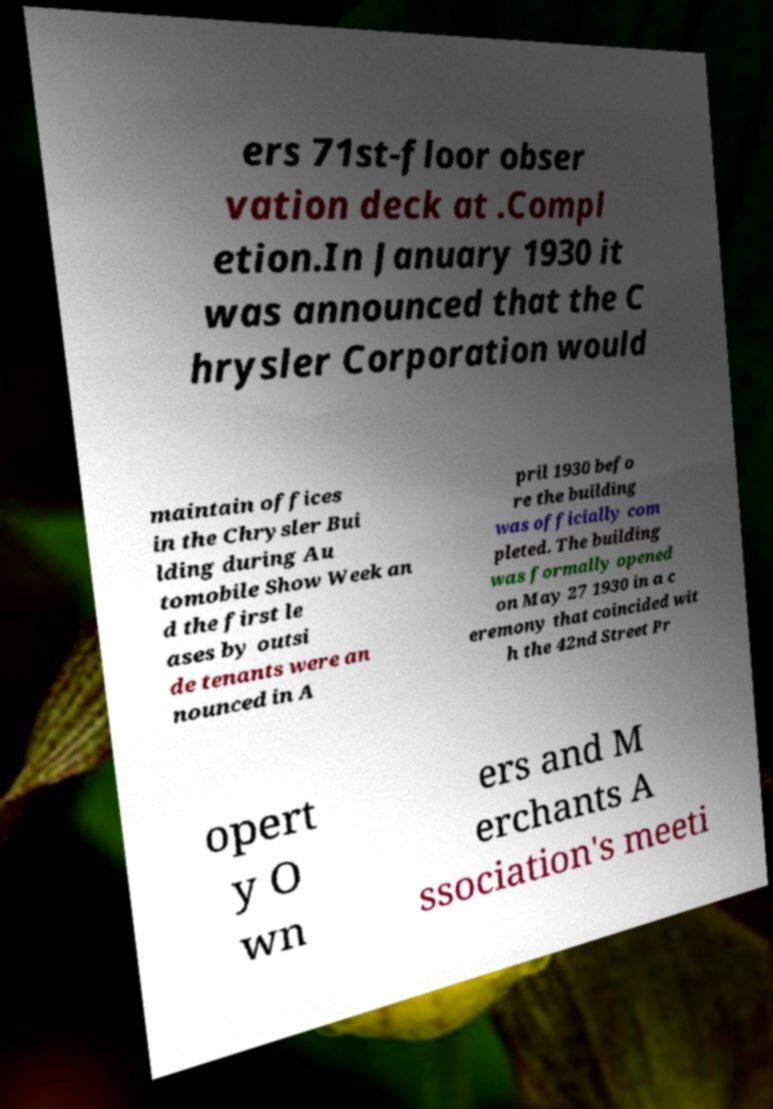Can you accurately transcribe the text from the provided image for me? ers 71st-floor obser vation deck at .Compl etion.In January 1930 it was announced that the C hrysler Corporation would maintain offices in the Chrysler Bui lding during Au tomobile Show Week an d the first le ases by outsi de tenants were an nounced in A pril 1930 befo re the building was officially com pleted. The building was formally opened on May 27 1930 in a c eremony that coincided wit h the 42nd Street Pr opert y O wn ers and M erchants A ssociation's meeti 